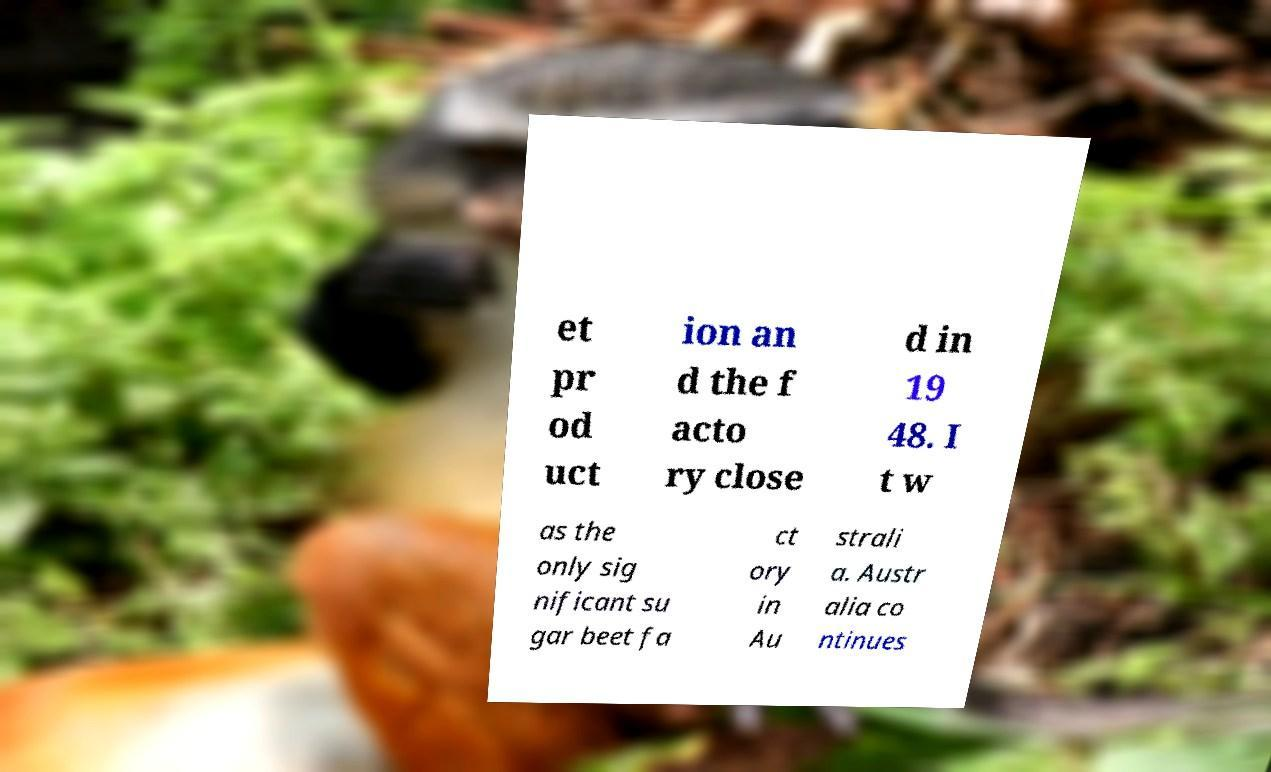For documentation purposes, I need the text within this image transcribed. Could you provide that? et pr od uct ion an d the f acto ry close d in 19 48. I t w as the only sig nificant su gar beet fa ct ory in Au strali a. Austr alia co ntinues 